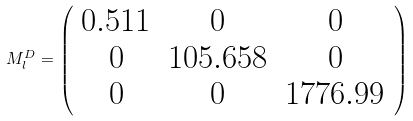Convert formula to latex. <formula><loc_0><loc_0><loc_500><loc_500>M _ { l } ^ { D } = \left ( \begin{array} { c c c } 0 . 5 1 1 & 0 & 0 \\ 0 & 1 0 5 . 6 5 8 & 0 \\ 0 & 0 & 1 7 7 6 . 9 9 \end{array} \right )</formula> 